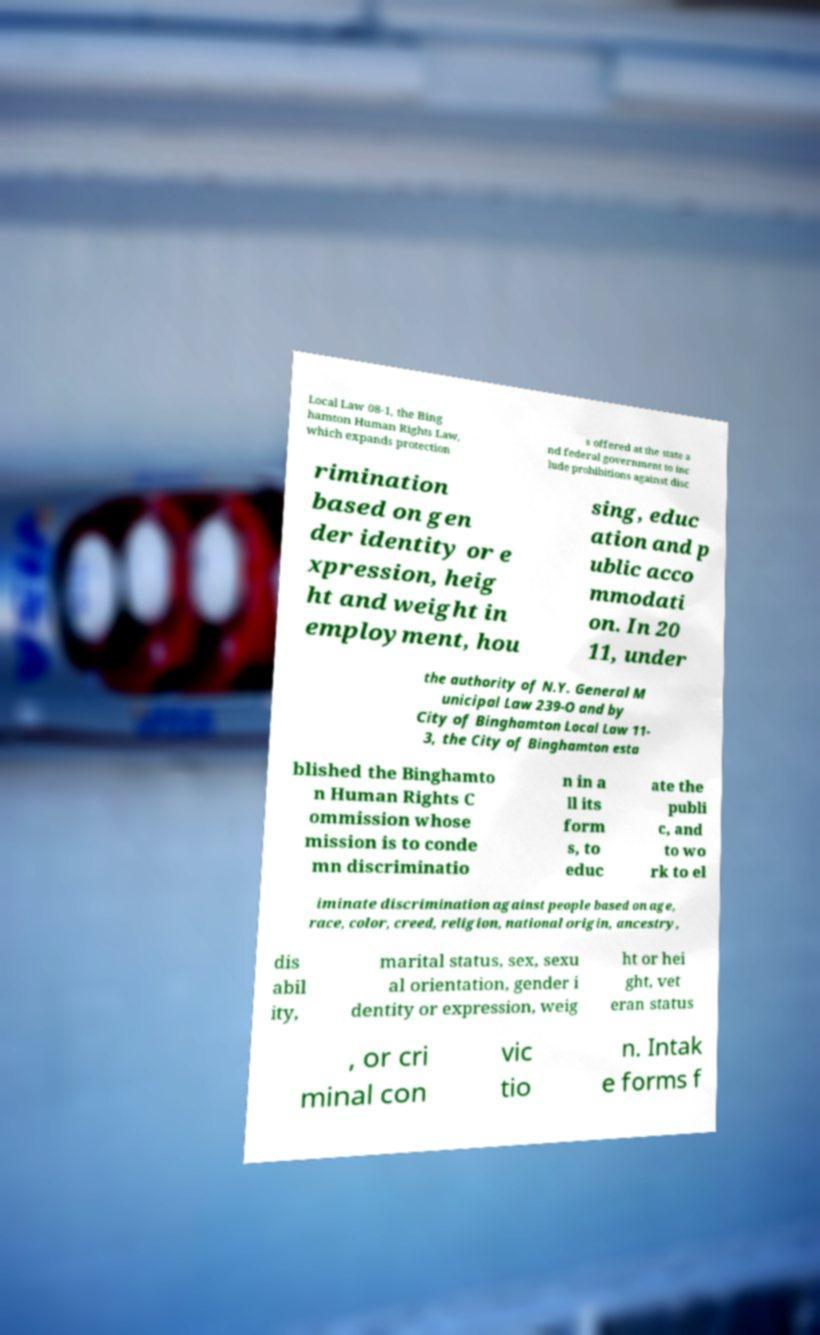I need the written content from this picture converted into text. Can you do that? Local Law 08-1, the Bing hamton Human Rights Law, which expands protection s offered at the state a nd federal government to inc lude prohibitions against disc rimination based on gen der identity or e xpression, heig ht and weight in employment, hou sing, educ ation and p ublic acco mmodati on. In 20 11, under the authority of N.Y. General M unicipal Law 239-O and by City of Binghamton Local Law 11- 3, the City of Binghamton esta blished the Binghamto n Human Rights C ommission whose mission is to conde mn discriminatio n in a ll its form s, to educ ate the publi c, and to wo rk to el iminate discrimination against people based on age, race, color, creed, religion, national origin, ancestry, dis abil ity, marital status, sex, sexu al orientation, gender i dentity or expression, weig ht or hei ght, vet eran status , or cri minal con vic tio n. Intak e forms f 